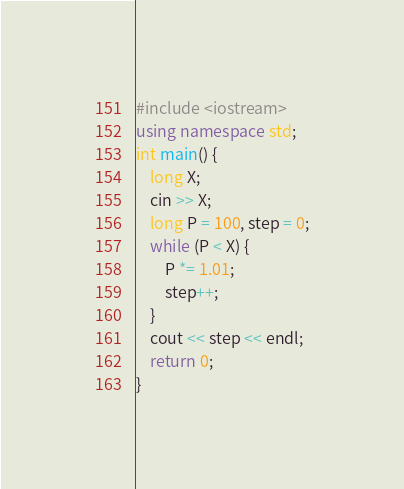<code> <loc_0><loc_0><loc_500><loc_500><_C++_>#include <iostream>
using namespace std;
int main() {
	long X;
	cin >> X;
	long P = 100, step = 0;
	while (P < X) {
		P *= 1.01;
		step++;
	}
	cout << step << endl;
	return 0;
}</code> 